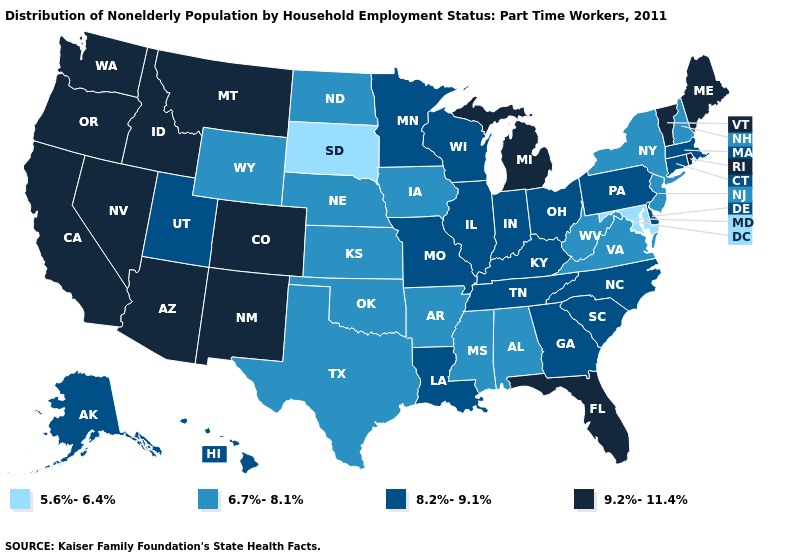Name the states that have a value in the range 5.6%-6.4%?
Keep it brief. Maryland, South Dakota. Name the states that have a value in the range 9.2%-11.4%?
Be succinct. Arizona, California, Colorado, Florida, Idaho, Maine, Michigan, Montana, Nevada, New Mexico, Oregon, Rhode Island, Vermont, Washington. Which states have the lowest value in the USA?
Answer briefly. Maryland, South Dakota. Which states have the lowest value in the West?
Write a very short answer. Wyoming. Does Arkansas have a higher value than South Dakota?
Give a very brief answer. Yes. Name the states that have a value in the range 8.2%-9.1%?
Give a very brief answer. Alaska, Connecticut, Delaware, Georgia, Hawaii, Illinois, Indiana, Kentucky, Louisiana, Massachusetts, Minnesota, Missouri, North Carolina, Ohio, Pennsylvania, South Carolina, Tennessee, Utah, Wisconsin. Name the states that have a value in the range 6.7%-8.1%?
Concise answer only. Alabama, Arkansas, Iowa, Kansas, Mississippi, Nebraska, New Hampshire, New Jersey, New York, North Dakota, Oklahoma, Texas, Virginia, West Virginia, Wyoming. What is the value of Rhode Island?
Answer briefly. 9.2%-11.4%. Name the states that have a value in the range 9.2%-11.4%?
Short answer required. Arizona, California, Colorado, Florida, Idaho, Maine, Michigan, Montana, Nevada, New Mexico, Oregon, Rhode Island, Vermont, Washington. What is the value of New Mexico?
Short answer required. 9.2%-11.4%. Does the first symbol in the legend represent the smallest category?
Short answer required. Yes. What is the lowest value in the West?
Keep it brief. 6.7%-8.1%. Does South Carolina have a higher value than Nebraska?
Short answer required. Yes. Which states have the lowest value in the West?
Quick response, please. Wyoming. Among the states that border Vermont , which have the highest value?
Quick response, please. Massachusetts. 